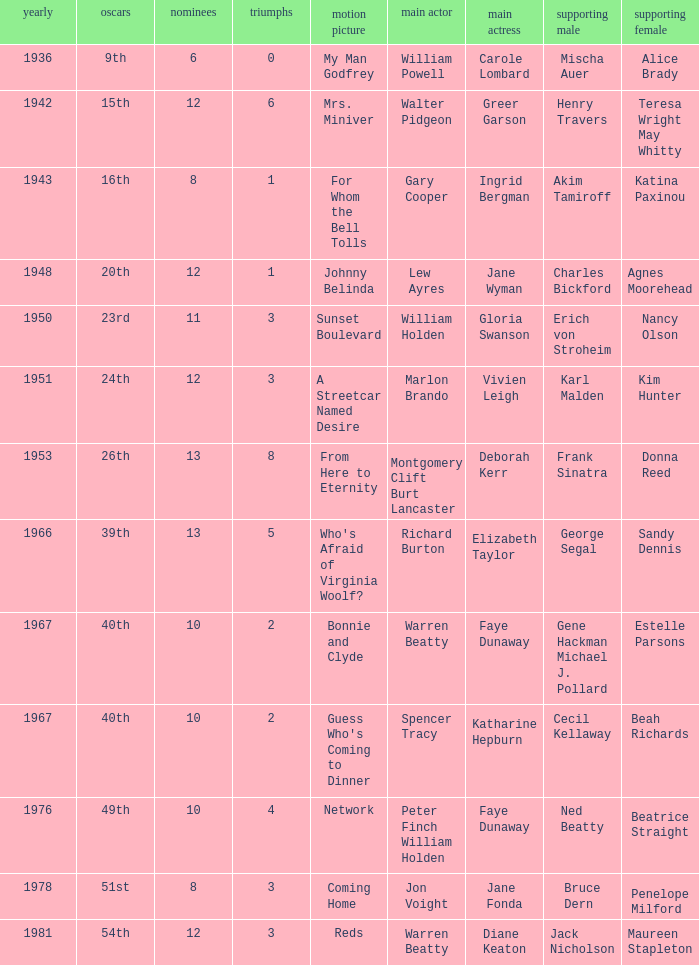Who was the leading actor in the film with a supporting actor named Cecil Kellaway? Spencer Tracy. 